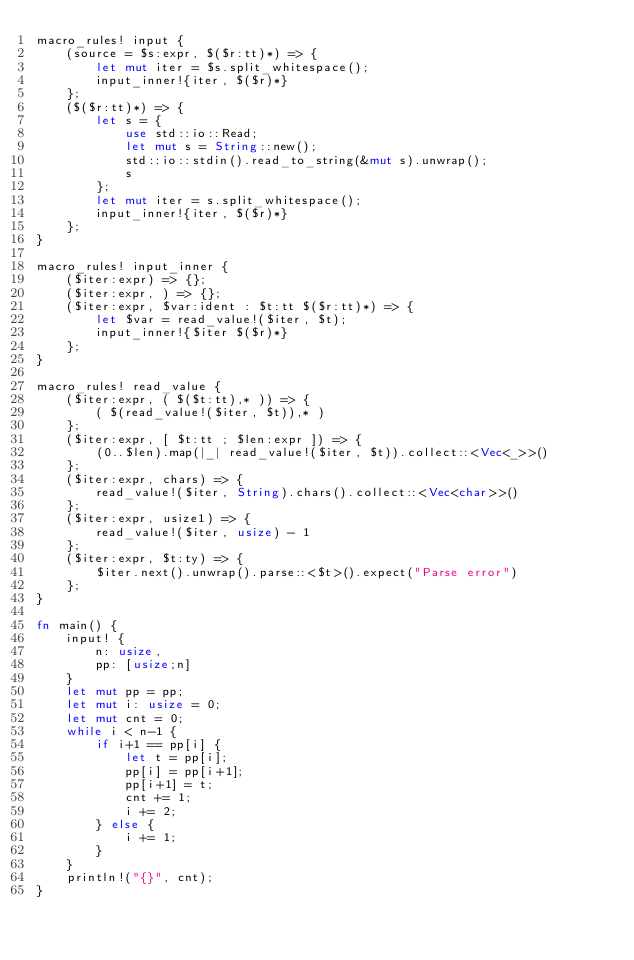Convert code to text. <code><loc_0><loc_0><loc_500><loc_500><_Rust_>macro_rules! input {
    (source = $s:expr, $($r:tt)*) => {
        let mut iter = $s.split_whitespace();
        input_inner!{iter, $($r)*}
    };
    ($($r:tt)*) => {
        let s = {
            use std::io::Read;
            let mut s = String::new();
            std::io::stdin().read_to_string(&mut s).unwrap();
            s
        };
        let mut iter = s.split_whitespace();
        input_inner!{iter, $($r)*}
    };
}

macro_rules! input_inner {
    ($iter:expr) => {};
    ($iter:expr, ) => {};
    ($iter:expr, $var:ident : $t:tt $($r:tt)*) => {
        let $var = read_value!($iter, $t);
        input_inner!{$iter $($r)*}
    };
}

macro_rules! read_value {
    ($iter:expr, ( $($t:tt),* )) => {
        ( $(read_value!($iter, $t)),* )
    };
    ($iter:expr, [ $t:tt ; $len:expr ]) => {
        (0..$len).map(|_| read_value!($iter, $t)).collect::<Vec<_>>()
    };
    ($iter:expr, chars) => {
        read_value!($iter, String).chars().collect::<Vec<char>>()
    };
    ($iter:expr, usize1) => {
        read_value!($iter, usize) - 1
    };
    ($iter:expr, $t:ty) => {
        $iter.next().unwrap().parse::<$t>().expect("Parse error")
    };
}

fn main() {
    input! {
        n: usize,
        pp: [usize;n]
    }
    let mut pp = pp;
    let mut i: usize = 0;
    let mut cnt = 0;
    while i < n-1 {
        if i+1 == pp[i] {
            let t = pp[i];
            pp[i] = pp[i+1];
            pp[i+1] = t;
            cnt += 1;
            i += 2;
        } else {
            i += 1;
        }
    }
    println!("{}", cnt);
}
</code> 